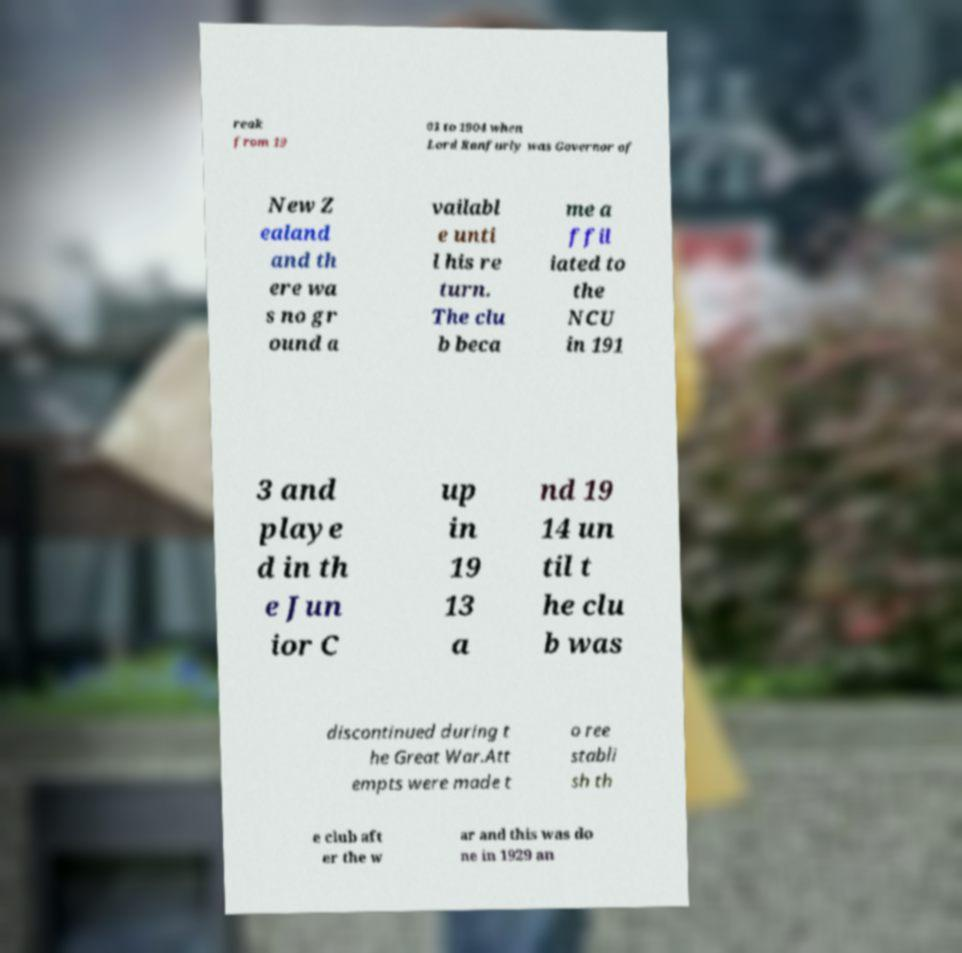Please identify and transcribe the text found in this image. reak from 19 01 to 1904 when Lord Ranfurly was Governor of New Z ealand and th ere wa s no gr ound a vailabl e unti l his re turn. The clu b beca me a ffil iated to the NCU in 191 3 and playe d in th e Jun ior C up in 19 13 a nd 19 14 un til t he clu b was discontinued during t he Great War.Att empts were made t o ree stabli sh th e club aft er the w ar and this was do ne in 1929 an 